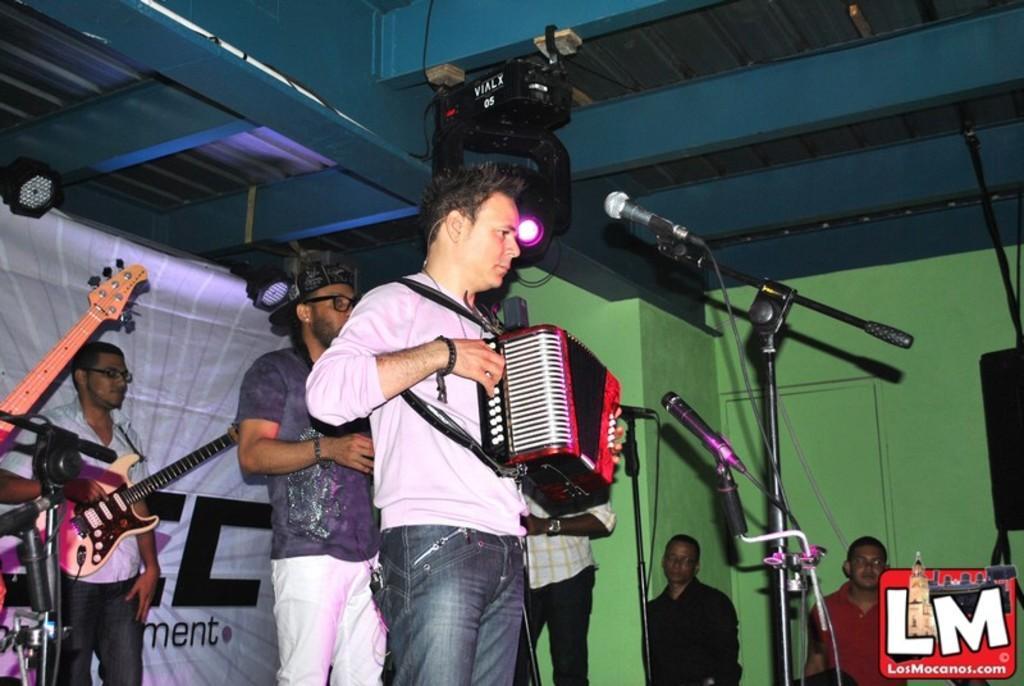Can you describe this image briefly? There are four men on the stage. To the front there is a man with white t-shirt is standing and playing a musical instrument. In front of him there is a mic. Behind him there is a man with grey and cap on his head. To the left side there is a man with white shirt is standing and playing guitar. To the right side there are two men standing. On the top there is a light. In the background there is a poster. 